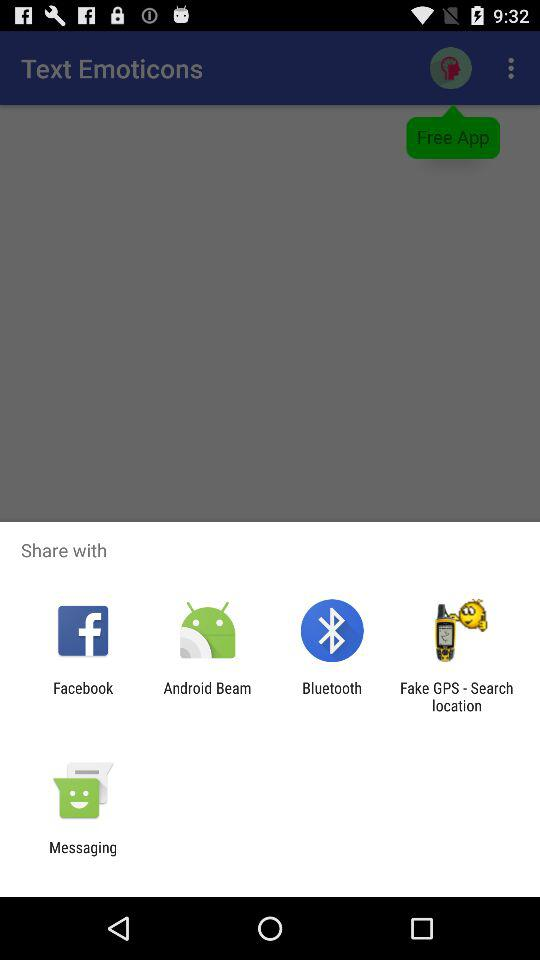Which application can I use to share? You can use the "Facebook", "Android Beam", "Bluetooth", "Fake GPS - Search location" and "Messaging" applications. 